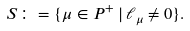Convert formula to latex. <formula><loc_0><loc_0><loc_500><loc_500>S \colon = \{ \mu \in P ^ { + } \, | \, \ell _ { \mu } \ne 0 \} .</formula> 